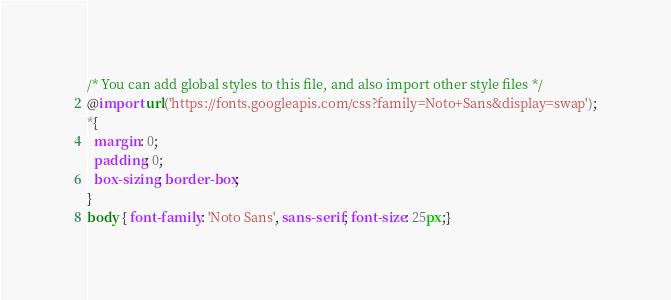<code> <loc_0><loc_0><loc_500><loc_500><_CSS_>/* You can add global styles to this file, and also import other style files */
@import url('https://fonts.googleapis.com/css?family=Noto+Sans&display=swap');
*{
  margin: 0;
  padding: 0;
  box-sizing: border-box;
}
body { font-family: 'Noto Sans', sans-serif; font-size: 25px;}</code> 